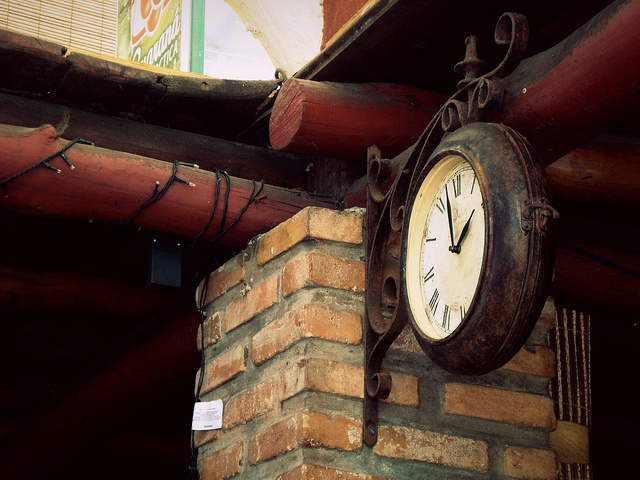Describe the objects in this image and their specific colors. I can see a clock in tan, ivory, and black tones in this image. 